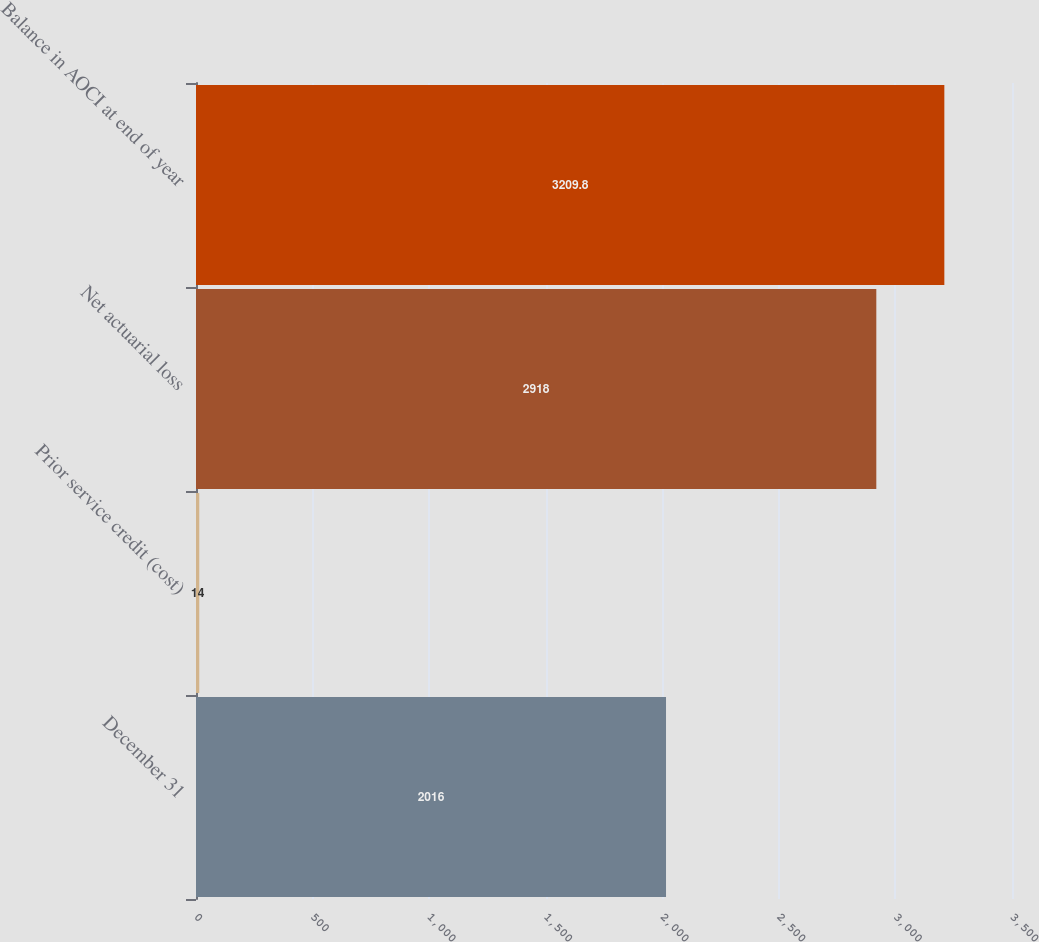Convert chart. <chart><loc_0><loc_0><loc_500><loc_500><bar_chart><fcel>December 31<fcel>Prior service credit (cost)<fcel>Net actuarial loss<fcel>Balance in AOCI at end of year<nl><fcel>2016<fcel>14<fcel>2918<fcel>3209.8<nl></chart> 